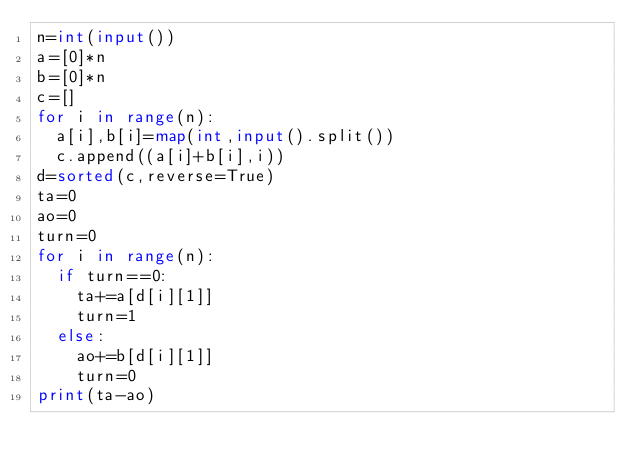<code> <loc_0><loc_0><loc_500><loc_500><_Python_>n=int(input())
a=[0]*n
b=[0]*n
c=[]
for i in range(n):
	a[i],b[i]=map(int,input().split())
	c.append((a[i]+b[i],i))
d=sorted(c,reverse=True)
ta=0
ao=0
turn=0
for i in range(n):
	if turn==0:
		ta+=a[d[i][1]]
		turn=1
	else:
		ao+=b[d[i][1]]
		turn=0
print(ta-ao)</code> 